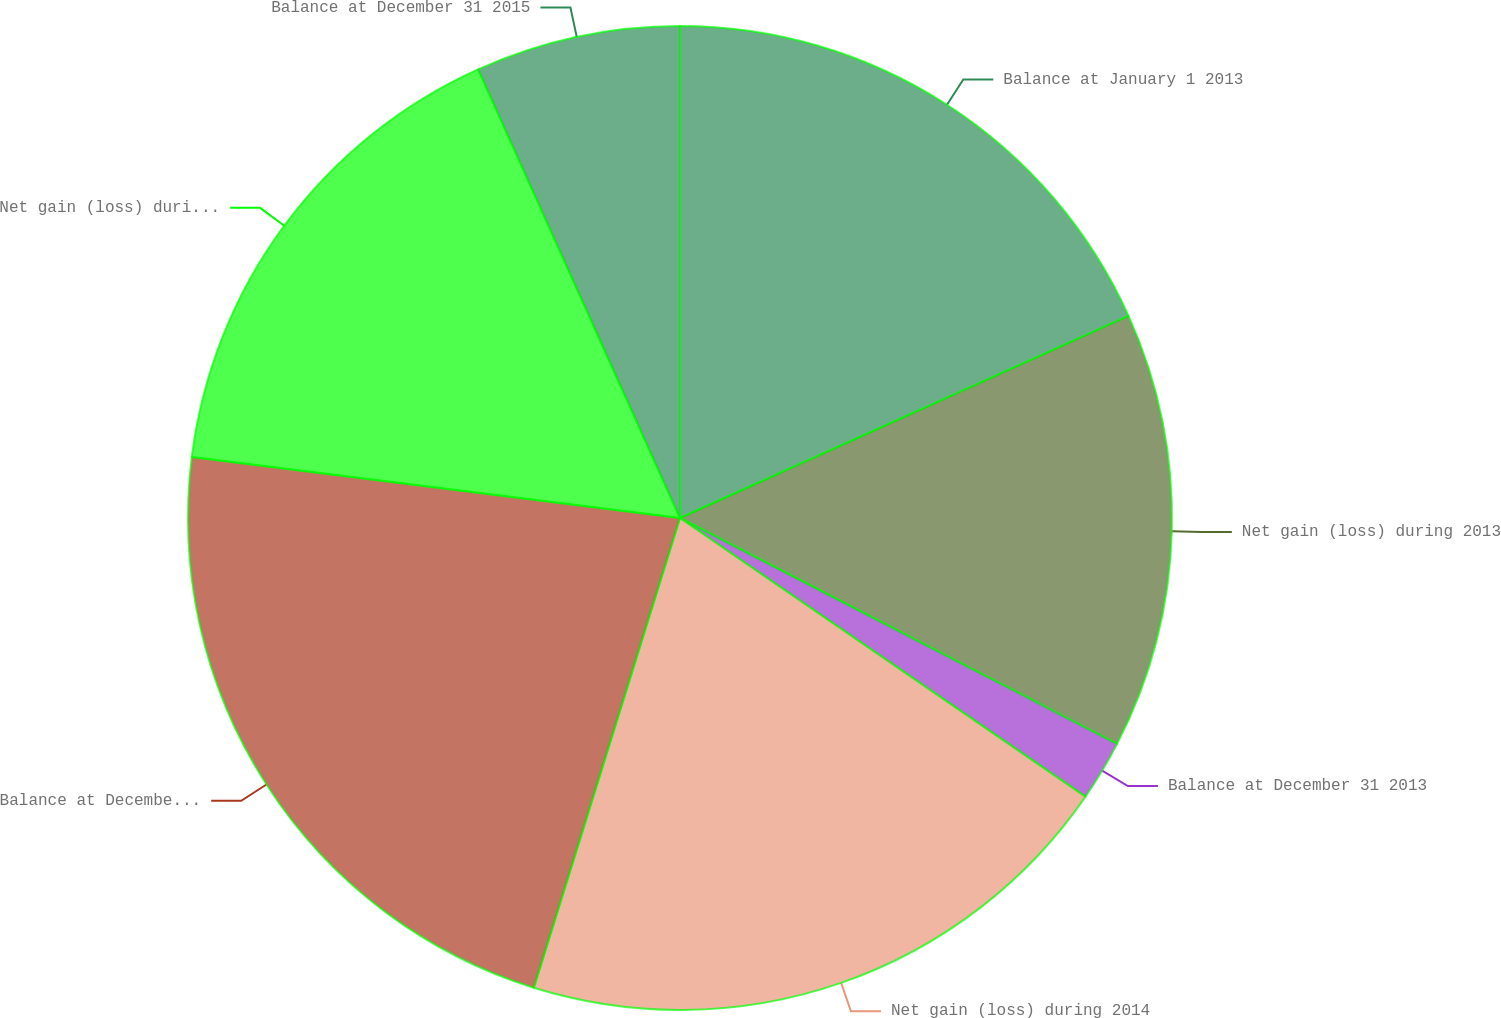<chart> <loc_0><loc_0><loc_500><loc_500><pie_chart><fcel>Balance at January 1 2013<fcel>Net gain (loss) during 2013<fcel>Balance at December 31 2013<fcel>Net gain (loss) during 2014<fcel>Balance at December 31 2014<fcel>Net gain (loss) during 2015<fcel>Balance at December 31 2015<nl><fcel>18.26%<fcel>14.33%<fcel>1.99%<fcel>20.22%<fcel>22.18%<fcel>16.29%<fcel>6.73%<nl></chart> 